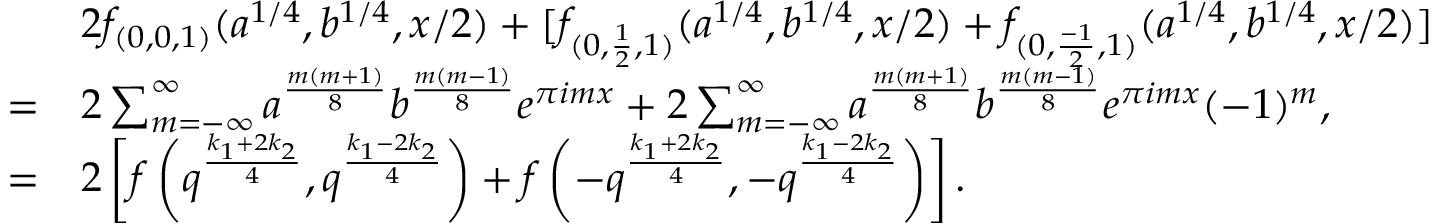Convert formula to latex. <formula><loc_0><loc_0><loc_500><loc_500>\begin{array} { r l } & { 2 f _ { ( 0 , 0 , 1 ) } ( a ^ { 1 / 4 } , b ^ { 1 / 4 } , x / 2 ) + [ f _ { ( 0 , \frac { 1 } { 2 } , 1 ) } ( a ^ { 1 / 4 } , b ^ { 1 / 4 } , x / 2 ) + f _ { ( 0 , \frac { - 1 } { 2 } , 1 ) } ( a ^ { 1 / 4 } , b ^ { 1 / 4 } , x / 2 ) ] } \\ { = } & { 2 \sum _ { m = - \infty } ^ { \infty } a ^ { \frac { m ( m + 1 ) } { 8 } } b ^ { \frac { m ( m - 1 ) } { 8 } } e ^ { \pi i m x } + 2 \sum _ { m = - \infty } ^ { \infty } a ^ { \frac { m ( m + 1 ) } { 8 } } b ^ { \frac { m ( m - 1 ) } { 8 } } e ^ { \pi i m x } ( - 1 ) ^ { m } , } \\ { = } & { 2 \left [ f \left ( q ^ { \frac { k _ { 1 } + 2 k _ { 2 } } { 4 } } , q ^ { \frac { k _ { 1 } - 2 k _ { 2 } } { 4 } } \right ) + f \left ( - q ^ { \frac { k _ { 1 } + 2 k _ { 2 } } { 4 } } , - q ^ { \frac { k _ { 1 } - 2 k _ { 2 } } { 4 } } \right ) \right ] . } \end{array}</formula> 